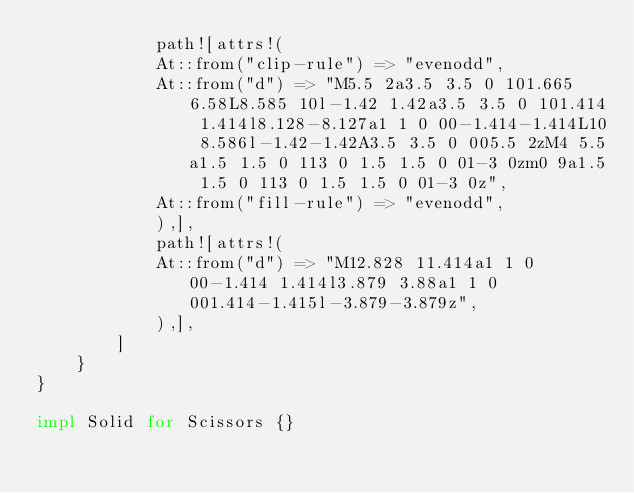Convert code to text. <code><loc_0><loc_0><loc_500><loc_500><_Rust_>            path![attrs!(
            At::from("clip-rule") => "evenodd",
            At::from("d") => "M5.5 2a3.5 3.5 0 101.665 6.58L8.585 10l-1.42 1.42a3.5 3.5 0 101.414 1.414l8.128-8.127a1 1 0 00-1.414-1.414L10 8.586l-1.42-1.42A3.5 3.5 0 005.5 2zM4 5.5a1.5 1.5 0 113 0 1.5 1.5 0 01-3 0zm0 9a1.5 1.5 0 113 0 1.5 1.5 0 01-3 0z",
            At::from("fill-rule") => "evenodd",
            ),],
            path![attrs!(
            At::from("d") => "M12.828 11.414a1 1 0 00-1.414 1.414l3.879 3.88a1 1 0 001.414-1.415l-3.879-3.879z",
            ),],
        ]
    }
}

impl Solid for Scissors {}
</code> 